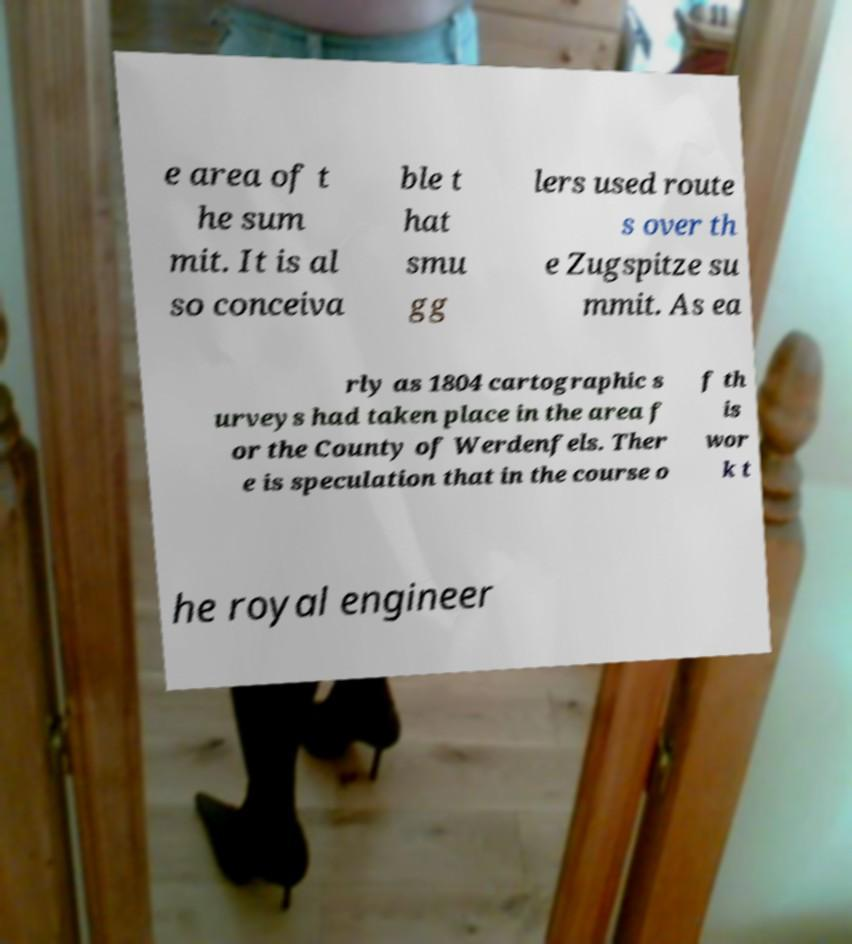Please read and relay the text visible in this image. What does it say? e area of t he sum mit. It is al so conceiva ble t hat smu gg lers used route s over th e Zugspitze su mmit. As ea rly as 1804 cartographic s urveys had taken place in the area f or the County of Werdenfels. Ther e is speculation that in the course o f th is wor k t he royal engineer 